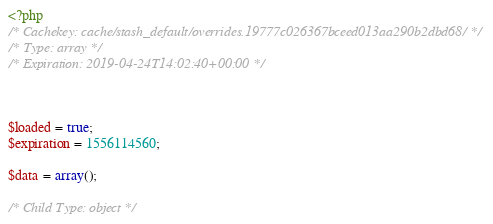<code> <loc_0><loc_0><loc_500><loc_500><_PHP_><?php 
/* Cachekey: cache/stash_default/overrides.19777c026367bceed013aa290b2dbd68/ */
/* Type: array */
/* Expiration: 2019-04-24T14:02:40+00:00 */



$loaded = true;
$expiration = 1556114560;

$data = array();

/* Child Type: object */</code> 